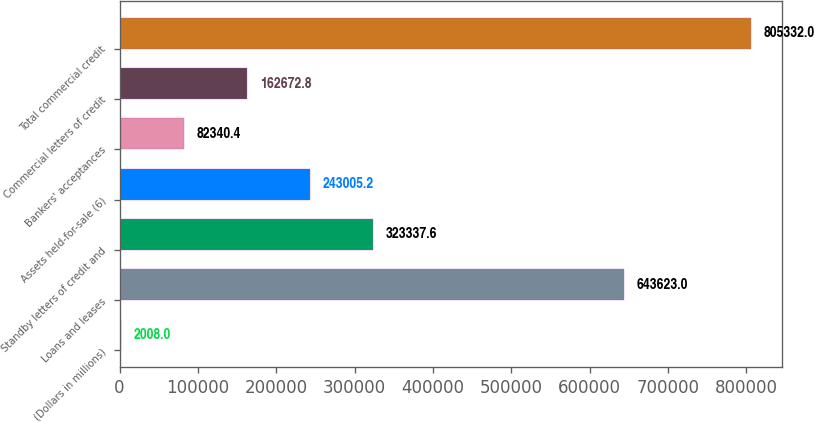Convert chart to OTSL. <chart><loc_0><loc_0><loc_500><loc_500><bar_chart><fcel>(Dollars in millions)<fcel>Loans and leases<fcel>Standby letters of credit and<fcel>Assets held-for-sale (6)<fcel>Bankers' acceptances<fcel>Commercial letters of credit<fcel>Total commercial credit<nl><fcel>2008<fcel>643623<fcel>323338<fcel>243005<fcel>82340.4<fcel>162673<fcel>805332<nl></chart> 